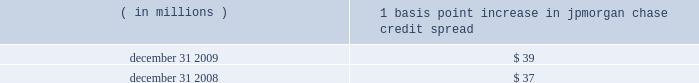Management 2019s discussion and analysis jpmorgan chase & co./2009 annual report 130 the following histogram illustrates the daily market risk 2013related gains and losses for ib and consumer/cio positions for 2009 .
The chart shows that the firm posted market risk 2013related gains on 227 out of 261 days in this period , with 69 days exceeding $ 160 million .
The inset graph looks at those days on which the firm experienced losses and depicts the amount by which the 95% ( 95 % ) confidence level var exceeded the actual loss on each of those days .
Losses were sustained on 34 days during 2009 and exceeded the var measure on one day due to high market volatility in the first quarter of 2009 .
Under the 95% ( 95 % ) confidence interval , the firm would expect to incur daily losses greater than that pre- dicted by var estimates about twelve times a year .
The table provides information about the gross sensitivity of dva to a one-basis-point increase in jpmorgan chase 2019s credit spreads .
This sensitivity represents the impact from a one-basis-point parallel shift in jpmorgan chase 2019s entire credit curve .
As credit curves do not typically move in a parallel fashion , the sensitivity multiplied by the change in spreads at a single maturity point may not be representative of the actual revenue recognized .
Debit valuation adjustment sensitivity 1 basis point increase in ( in millions ) jpmorgan chase credit spread .
Loss advisories and drawdowns loss advisories and drawdowns are tools used to highlight to senior management trading losses above certain levels and initiate discus- sion of remedies .
Economic value stress testing while var reflects the risk of loss due to adverse changes in normal markets , stress testing captures the firm 2019s exposure to unlikely but plausible events in abnormal markets .
The firm conducts economic- value stress tests using multiple scenarios that assume credit spreads widen significantly , equity prices decline and significant changes in interest rates across the major currencies .
Other scenar- ios focus on the risks predominant in individual business segments and include scenarios that focus on the potential for adverse movements in complex portfolios .
Scenarios were updated more frequently in 2009 and , in some cases , redefined to reflect the signifi- cant market volatility which began in late 2008 .
Along with var , stress testing is important in measuring and controlling risk .
Stress testing enhances the understanding of the firm 2019s risk profile and loss potential , and stress losses are monitored against limits .
Stress testing is also utilized in one-off approvals and cross-business risk measurement , as well as an input to economic capital allocation .
Stress-test results , trends and explanations based on current market risk positions are reported to the firm 2019s senior management and to the lines of business to help them better measure and manage risks and to understand event risk 2013sensitive positions. .
What was the percent of the basis point increase in jpmorgan chase credit spread from 2008 \\n to 2009? 
Computations: ((39 - 37) / 37)
Answer: 0.05405. 